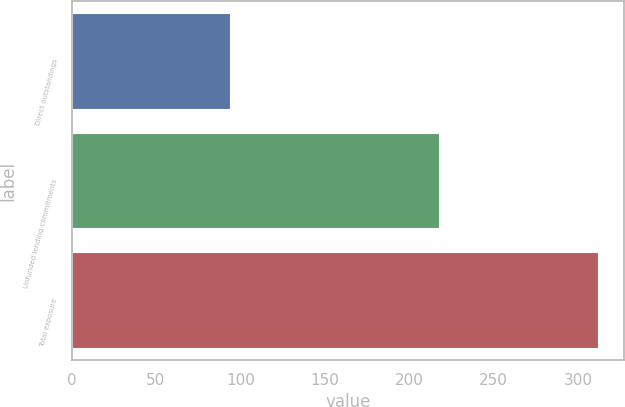Convert chart. <chart><loc_0><loc_0><loc_500><loc_500><bar_chart><fcel>Direct outstandings<fcel>Unfunded lending commitments<fcel>Total exposure<nl><fcel>94<fcel>218<fcel>312<nl></chart> 